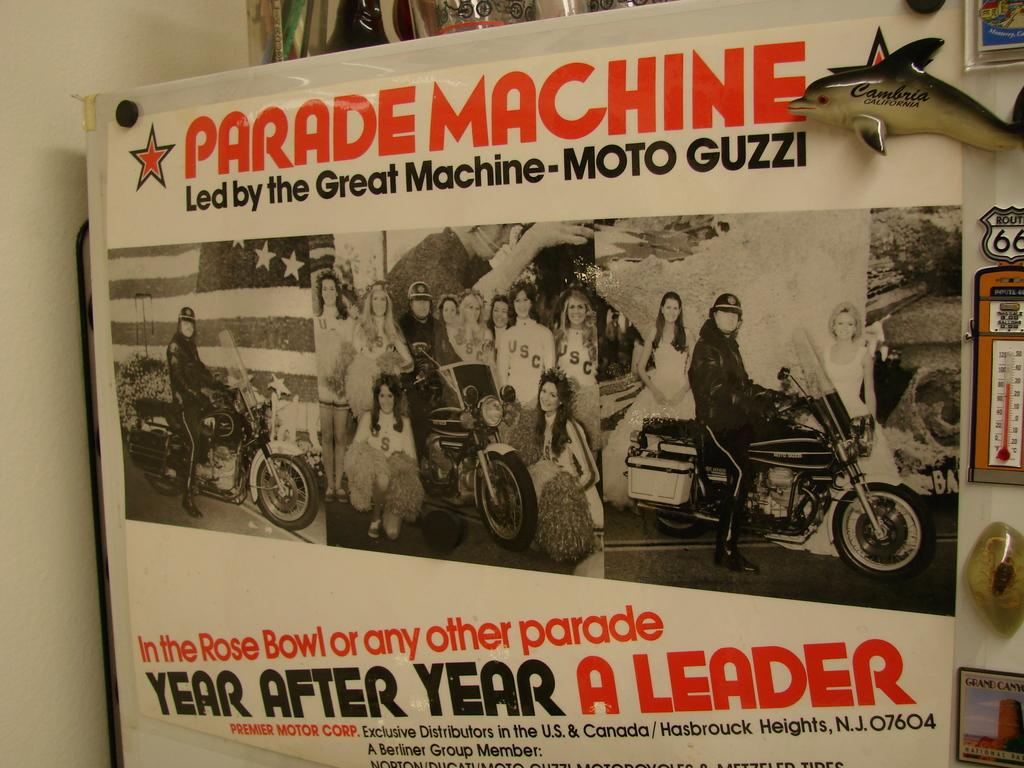<image>
Offer a succinct explanation of the picture presented. a sign that says year after year on it 